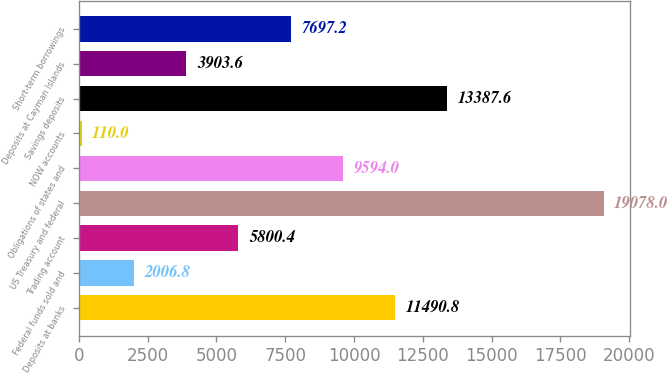Convert chart. <chart><loc_0><loc_0><loc_500><loc_500><bar_chart><fcel>Deposits at banks<fcel>Federal funds sold and<fcel>Trading account<fcel>US Treasury and federal<fcel>Obligations of states and<fcel>NOW accounts<fcel>Savings deposits<fcel>Deposits at Cayman Islands<fcel>Short-term borrowings<nl><fcel>11490.8<fcel>2006.8<fcel>5800.4<fcel>19078<fcel>9594<fcel>110<fcel>13387.6<fcel>3903.6<fcel>7697.2<nl></chart> 